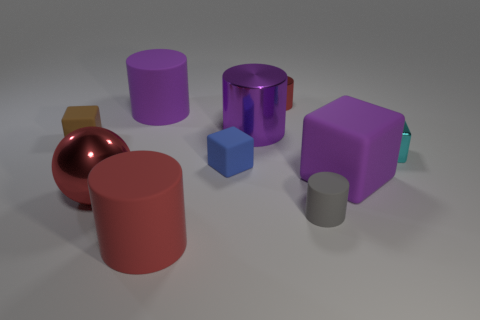Are there any other things that have the same shape as the big red metallic object?
Ensure brevity in your answer.  No. How many other things are the same shape as the blue object?
Your answer should be very brief. 3. There is a metallic cylinder that is the same size as the metal ball; what is its color?
Provide a short and direct response. Purple. What number of objects are tiny matte cylinders or spheres?
Make the answer very short. 2. There is a cyan metal object; are there any rubber blocks behind it?
Keep it short and to the point. Yes. Are there any cyan balls that have the same material as the tiny blue block?
Your response must be concise. No. The matte cylinder that is the same color as the large ball is what size?
Keep it short and to the point. Large. How many cubes are either big yellow metal objects or tiny rubber things?
Provide a short and direct response. 2. Is the number of tiny rubber things on the left side of the purple shiny cylinder greater than the number of tiny red objects that are left of the large red metal ball?
Offer a terse response. Yes. How many small rubber cylinders are the same color as the sphere?
Your answer should be very brief. 0. 